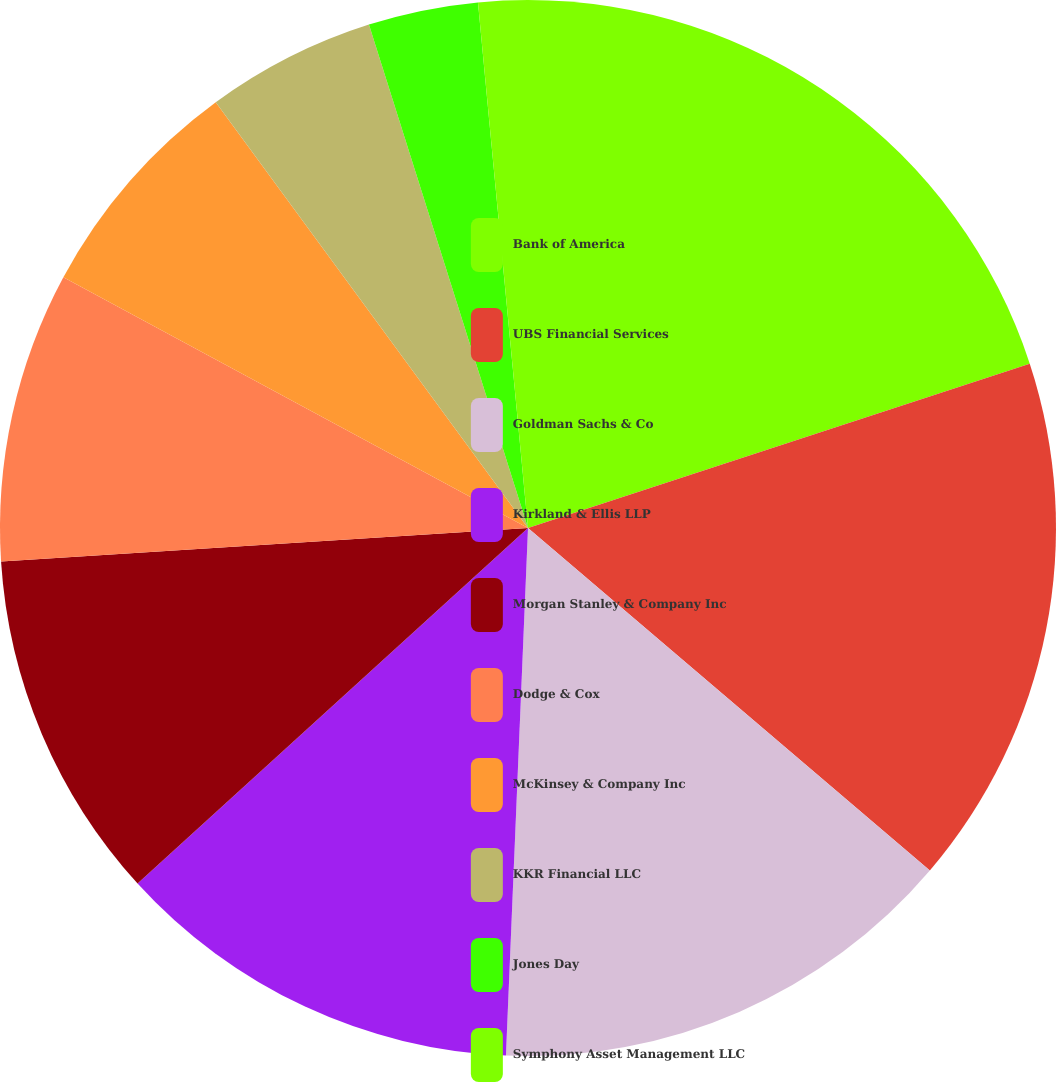Convert chart. <chart><loc_0><loc_0><loc_500><loc_500><pie_chart><fcel>Bank of America<fcel>UBS Financial Services<fcel>Goldman Sachs & Co<fcel>Kirkland & Ellis LLP<fcel>Morgan Stanley & Company Inc<fcel>Dodge & Cox<fcel>McKinsey & Company Inc<fcel>KKR Financial LLC<fcel>Jones Day<fcel>Symphony Asset Management LLC<nl><fcel>19.96%<fcel>16.27%<fcel>14.43%<fcel>12.58%<fcel>10.74%<fcel>8.89%<fcel>7.05%<fcel>5.2%<fcel>3.36%<fcel>1.51%<nl></chart> 